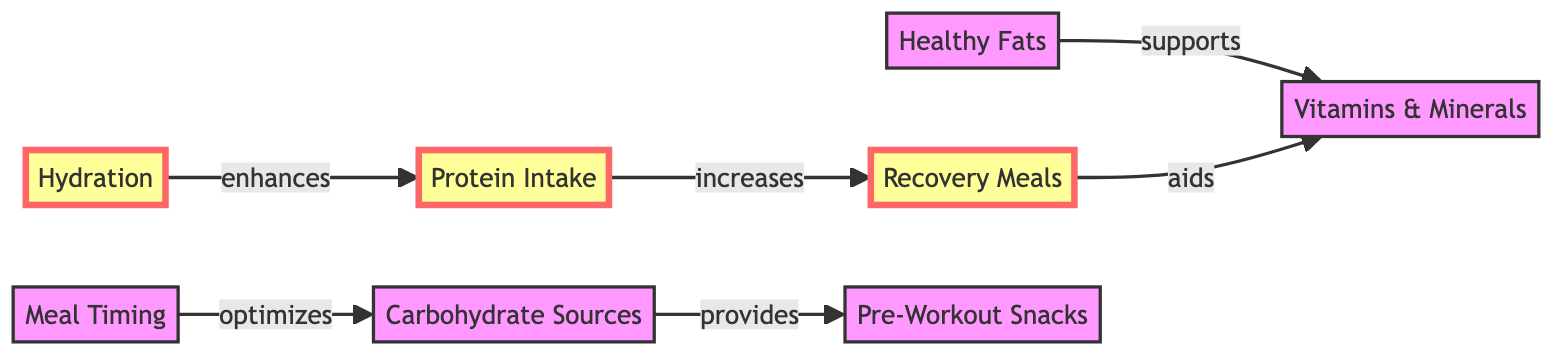What is the impact of Protein Intake on Recovery Meals? The diagram shows that Protein Intake increases Recovery Meals, indicating that a higher protein intake leads to a greater number of recovery meals consumed.
Answer: increases Which node provides quick digestible carbs for immediate energy during training? The node labeled "Carbohydrate Sources" has an edge labeled "provides" pointing to "Pre-Workout Snacks," confirming that Carbohydrate Sources offer quick carbs for energy.
Answer: Carbohydrate Sources How many nodes are present in the diagram? There are eight nodes listed within the data provided, each representing different components of the nutrition plan. Counting these gives a total of eight nodes.
Answer: eight What does Meal Timing optimize? The edge from Meal Timing to Carbohydrate Sources is labeled “optimizes,” which indicates that Meal Timing specifically enhances the use of Carbohydrate Sources.
Answer: Carbohydrate Sources Which component aids recovery meals? The diagram shows an edge from Recovery Meals pointing to Vitamins & Minerals with the label "aids," suggesting that Recovery Meals help improve the intake or effectiveness of Vitamins & Minerals.
Answer: Vitamins & Minerals How does Hydration affect Protein Intake? The direction of the edge from Hydration to Protein Intake is labeled "enhances," indicating that proper hydration positively influences protein intake, likely affecting muscles' ability to utilize protein effectively.
Answer: enhances Which dietary component supports healthy fats? The edge from Healthy Fats to Vitamins & Minerals labeled "supports" indicates that Healthy Fats play a supportive role in the uptake or functioning of Vitamins & Minerals.
Answer: Vitamins & Minerals What is the relationship between Recovery Meals and Vitamins & Minerals? The diagram indicates that Recovery Meals "aids" Vitamins & Minerals, suggesting a supportive connection where Recovery Meals enhance the benefits of Vitamins & Minerals for recovery.
Answer: aids 